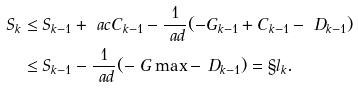Convert formula to latex. <formula><loc_0><loc_0><loc_500><loc_500>S _ { k } & \leq S _ { k - 1 } + \ a c C _ { k - 1 } - \frac { 1 } { \ a d } ( - G _ { k - 1 } + C _ { k - 1 } - \ D _ { k - 1 } ) \\ & \leq S _ { k - 1 } - \frac { 1 } { \ a d } ( - \ G \max - \ D _ { k - 1 } ) = \S l _ { k } .</formula> 